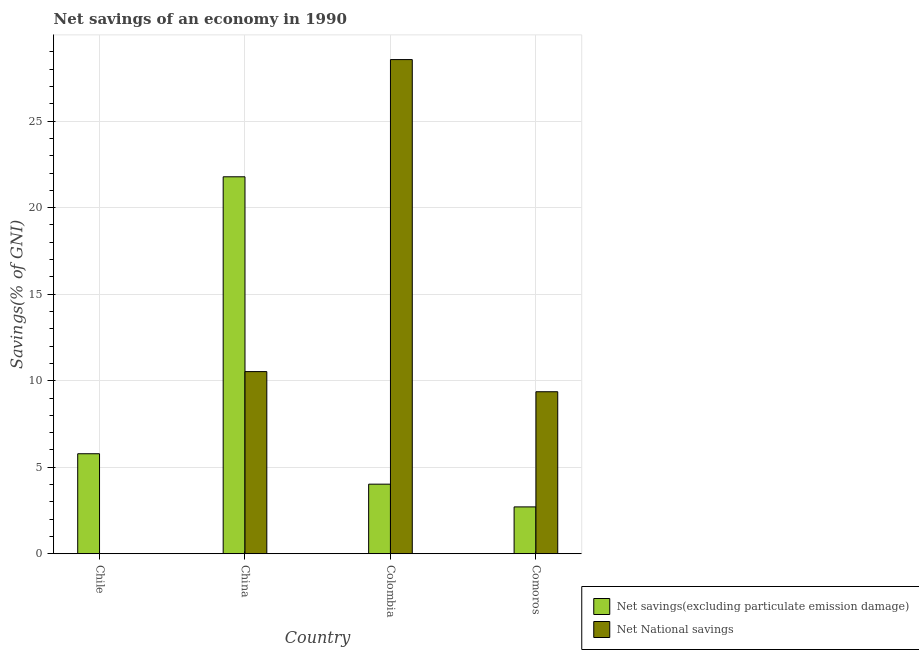Are the number of bars on each tick of the X-axis equal?
Your answer should be compact. No. How many bars are there on the 4th tick from the right?
Offer a very short reply. 1. What is the label of the 4th group of bars from the left?
Your answer should be very brief. Comoros. What is the net savings(excluding particulate emission damage) in China?
Your answer should be compact. 21.79. Across all countries, what is the maximum net national savings?
Offer a very short reply. 28.56. In which country was the net national savings maximum?
Your answer should be very brief. Colombia. What is the total net national savings in the graph?
Provide a succinct answer. 48.45. What is the difference between the net savings(excluding particulate emission damage) in China and that in Comoros?
Provide a short and direct response. 19.08. What is the difference between the net national savings in Comoros and the net savings(excluding particulate emission damage) in Chile?
Your response must be concise. 3.58. What is the average net savings(excluding particulate emission damage) per country?
Give a very brief answer. 8.57. What is the difference between the net national savings and net savings(excluding particulate emission damage) in Comoros?
Make the answer very short. 6.66. What is the ratio of the net savings(excluding particulate emission damage) in Chile to that in Comoros?
Provide a short and direct response. 2.13. What is the difference between the highest and the second highest net national savings?
Provide a short and direct response. 18.03. What is the difference between the highest and the lowest net national savings?
Offer a very short reply. 28.56. In how many countries, is the net national savings greater than the average net national savings taken over all countries?
Offer a terse response. 1. Is the sum of the net savings(excluding particulate emission damage) in Chile and China greater than the maximum net national savings across all countries?
Provide a succinct answer. No. How many bars are there?
Offer a very short reply. 7. Are the values on the major ticks of Y-axis written in scientific E-notation?
Keep it short and to the point. No. Does the graph contain any zero values?
Offer a terse response. Yes. Does the graph contain grids?
Ensure brevity in your answer.  Yes. Where does the legend appear in the graph?
Keep it short and to the point. Bottom right. How many legend labels are there?
Provide a succinct answer. 2. What is the title of the graph?
Ensure brevity in your answer.  Net savings of an economy in 1990. Does "Canada" appear as one of the legend labels in the graph?
Give a very brief answer. No. What is the label or title of the X-axis?
Offer a terse response. Country. What is the label or title of the Y-axis?
Ensure brevity in your answer.  Savings(% of GNI). What is the Savings(% of GNI) of Net savings(excluding particulate emission damage) in Chile?
Keep it short and to the point. 5.78. What is the Savings(% of GNI) in Net National savings in Chile?
Your response must be concise. 0. What is the Savings(% of GNI) of Net savings(excluding particulate emission damage) in China?
Give a very brief answer. 21.79. What is the Savings(% of GNI) of Net National savings in China?
Your response must be concise. 10.53. What is the Savings(% of GNI) in Net savings(excluding particulate emission damage) in Colombia?
Offer a very short reply. 4.02. What is the Savings(% of GNI) in Net National savings in Colombia?
Your response must be concise. 28.56. What is the Savings(% of GNI) in Net savings(excluding particulate emission damage) in Comoros?
Provide a short and direct response. 2.71. What is the Savings(% of GNI) in Net National savings in Comoros?
Offer a terse response. 9.36. Across all countries, what is the maximum Savings(% of GNI) of Net savings(excluding particulate emission damage)?
Provide a succinct answer. 21.79. Across all countries, what is the maximum Savings(% of GNI) of Net National savings?
Give a very brief answer. 28.56. Across all countries, what is the minimum Savings(% of GNI) of Net savings(excluding particulate emission damage)?
Your response must be concise. 2.71. What is the total Savings(% of GNI) in Net savings(excluding particulate emission damage) in the graph?
Your answer should be very brief. 34.29. What is the total Savings(% of GNI) of Net National savings in the graph?
Your answer should be very brief. 48.45. What is the difference between the Savings(% of GNI) in Net savings(excluding particulate emission damage) in Chile and that in China?
Your response must be concise. -16.01. What is the difference between the Savings(% of GNI) of Net savings(excluding particulate emission damage) in Chile and that in Colombia?
Provide a short and direct response. 1.76. What is the difference between the Savings(% of GNI) of Net savings(excluding particulate emission damage) in Chile and that in Comoros?
Ensure brevity in your answer.  3.07. What is the difference between the Savings(% of GNI) of Net savings(excluding particulate emission damage) in China and that in Colombia?
Your answer should be very brief. 17.76. What is the difference between the Savings(% of GNI) of Net National savings in China and that in Colombia?
Offer a terse response. -18.03. What is the difference between the Savings(% of GNI) in Net savings(excluding particulate emission damage) in China and that in Comoros?
Ensure brevity in your answer.  19.08. What is the difference between the Savings(% of GNI) in Net National savings in China and that in Comoros?
Offer a very short reply. 1.16. What is the difference between the Savings(% of GNI) of Net savings(excluding particulate emission damage) in Colombia and that in Comoros?
Your answer should be very brief. 1.31. What is the difference between the Savings(% of GNI) of Net National savings in Colombia and that in Comoros?
Offer a very short reply. 19.2. What is the difference between the Savings(% of GNI) of Net savings(excluding particulate emission damage) in Chile and the Savings(% of GNI) of Net National savings in China?
Keep it short and to the point. -4.75. What is the difference between the Savings(% of GNI) of Net savings(excluding particulate emission damage) in Chile and the Savings(% of GNI) of Net National savings in Colombia?
Give a very brief answer. -22.78. What is the difference between the Savings(% of GNI) in Net savings(excluding particulate emission damage) in Chile and the Savings(% of GNI) in Net National savings in Comoros?
Give a very brief answer. -3.58. What is the difference between the Savings(% of GNI) of Net savings(excluding particulate emission damage) in China and the Savings(% of GNI) of Net National savings in Colombia?
Give a very brief answer. -6.77. What is the difference between the Savings(% of GNI) in Net savings(excluding particulate emission damage) in China and the Savings(% of GNI) in Net National savings in Comoros?
Ensure brevity in your answer.  12.42. What is the difference between the Savings(% of GNI) of Net savings(excluding particulate emission damage) in Colombia and the Savings(% of GNI) of Net National savings in Comoros?
Your answer should be very brief. -5.34. What is the average Savings(% of GNI) in Net savings(excluding particulate emission damage) per country?
Your response must be concise. 8.57. What is the average Savings(% of GNI) in Net National savings per country?
Your response must be concise. 12.11. What is the difference between the Savings(% of GNI) in Net savings(excluding particulate emission damage) and Savings(% of GNI) in Net National savings in China?
Ensure brevity in your answer.  11.26. What is the difference between the Savings(% of GNI) in Net savings(excluding particulate emission damage) and Savings(% of GNI) in Net National savings in Colombia?
Offer a terse response. -24.54. What is the difference between the Savings(% of GNI) of Net savings(excluding particulate emission damage) and Savings(% of GNI) of Net National savings in Comoros?
Provide a short and direct response. -6.66. What is the ratio of the Savings(% of GNI) in Net savings(excluding particulate emission damage) in Chile to that in China?
Your answer should be compact. 0.27. What is the ratio of the Savings(% of GNI) in Net savings(excluding particulate emission damage) in Chile to that in Colombia?
Offer a terse response. 1.44. What is the ratio of the Savings(% of GNI) of Net savings(excluding particulate emission damage) in Chile to that in Comoros?
Provide a short and direct response. 2.13. What is the ratio of the Savings(% of GNI) of Net savings(excluding particulate emission damage) in China to that in Colombia?
Your response must be concise. 5.42. What is the ratio of the Savings(% of GNI) of Net National savings in China to that in Colombia?
Give a very brief answer. 0.37. What is the ratio of the Savings(% of GNI) of Net savings(excluding particulate emission damage) in China to that in Comoros?
Your answer should be very brief. 8.05. What is the ratio of the Savings(% of GNI) in Net National savings in China to that in Comoros?
Provide a succinct answer. 1.12. What is the ratio of the Savings(% of GNI) in Net savings(excluding particulate emission damage) in Colombia to that in Comoros?
Make the answer very short. 1.49. What is the ratio of the Savings(% of GNI) of Net National savings in Colombia to that in Comoros?
Provide a succinct answer. 3.05. What is the difference between the highest and the second highest Savings(% of GNI) of Net savings(excluding particulate emission damage)?
Provide a short and direct response. 16.01. What is the difference between the highest and the second highest Savings(% of GNI) in Net National savings?
Offer a terse response. 18.03. What is the difference between the highest and the lowest Savings(% of GNI) of Net savings(excluding particulate emission damage)?
Provide a succinct answer. 19.08. What is the difference between the highest and the lowest Savings(% of GNI) in Net National savings?
Your answer should be compact. 28.56. 